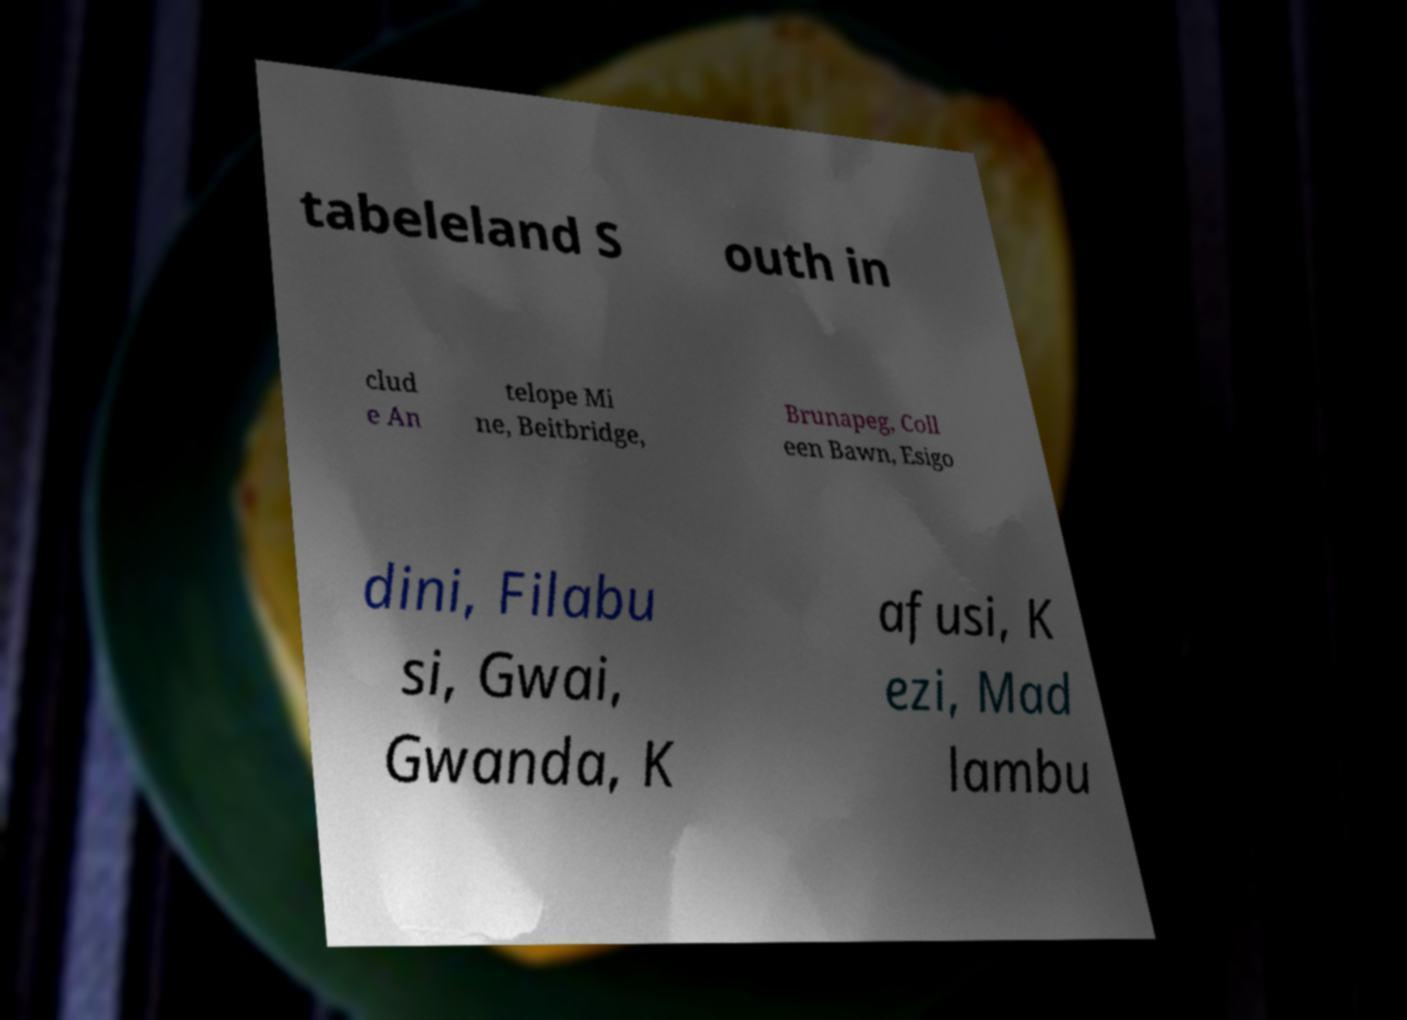Please identify and transcribe the text found in this image. tabeleland S outh in clud e An telope Mi ne, Beitbridge, Brunapeg, Coll een Bawn, Esigo dini, Filabu si, Gwai, Gwanda, K afusi, K ezi, Mad lambu 